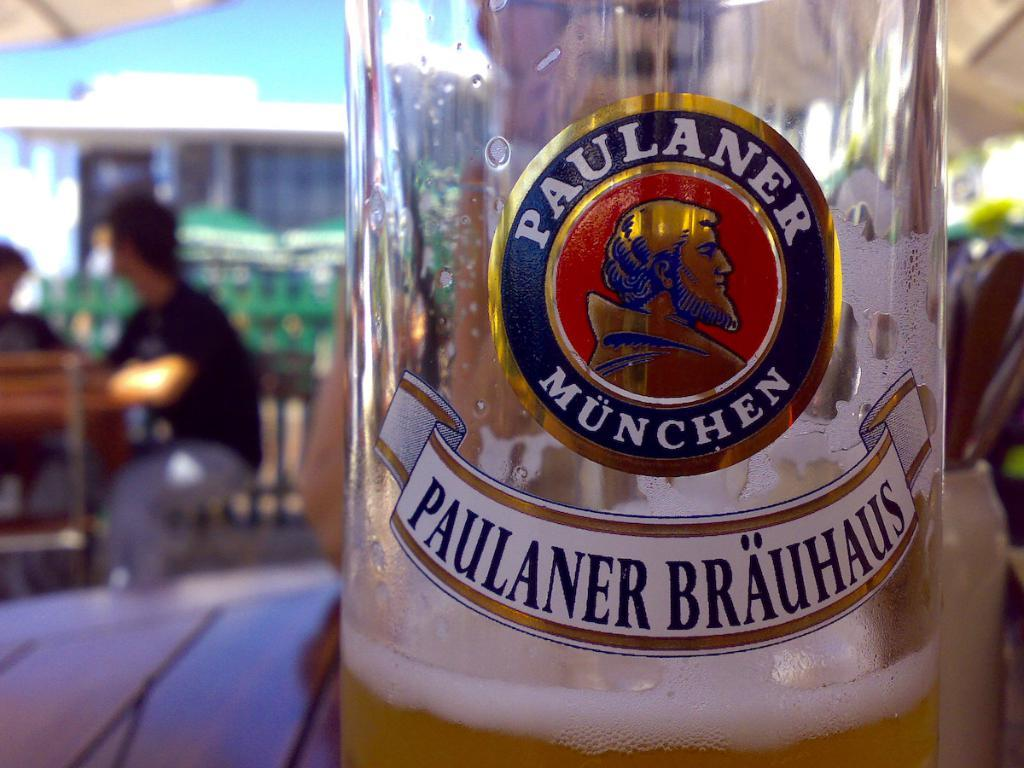What is in the bottle that is visible in the image? There is a drink in the bottle that is visible in the image. Where is the bottle located in the image? The bottle is placed on a table in the image. What can be seen in the background of the image? There are people sitting in chairs and another table in the background. What type of spring is visible in the image? There is no spring present in the image. What furniture can be seen in the image? The only furniture mentioned in the facts is the table where the bottle is placed. There is no other furniture explicitly mentioned in the image. 